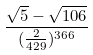Convert formula to latex. <formula><loc_0><loc_0><loc_500><loc_500>\frac { \sqrt { 5 } - \sqrt { 1 0 6 } } { ( \frac { 2 } { 4 2 9 } ) ^ { 3 6 6 } }</formula> 